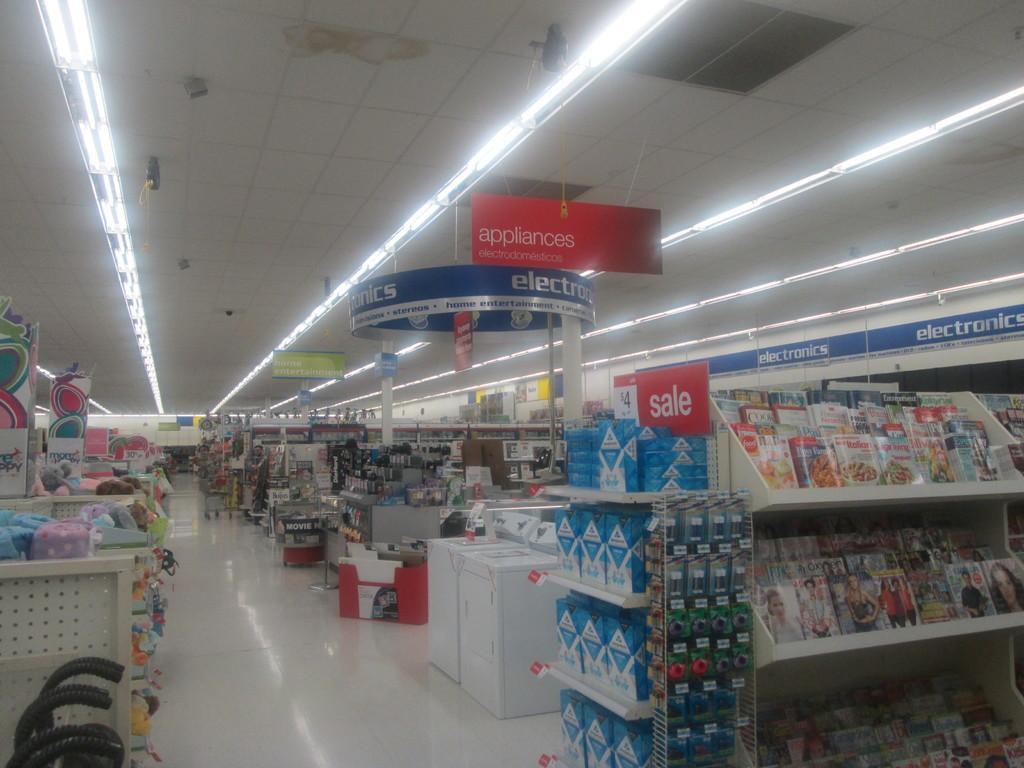<image>
Render a clear and concise summary of the photo. The appliances section of a store is right next to the electronics department. 